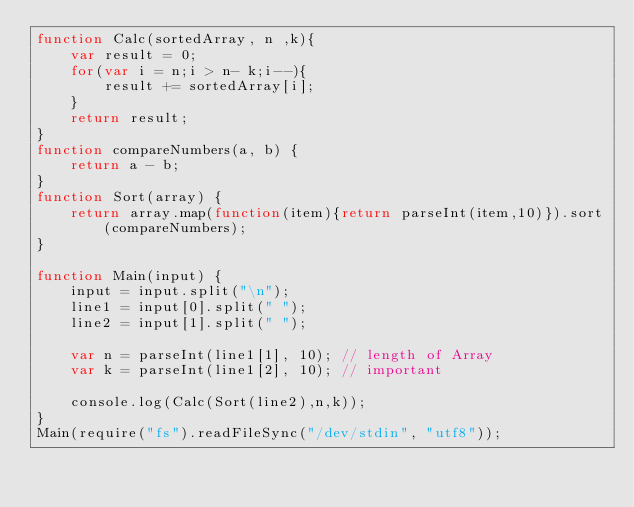<code> <loc_0><loc_0><loc_500><loc_500><_JavaScript_>function Calc(sortedArray, n ,k){
    var result = 0;
    for(var i = n;i > n- k;i--){
        result += sortedArray[i];
    }
    return result;
}
function compareNumbers(a, b) {
    return a - b;
}
function Sort(array) {
    return array.map(function(item){return parseInt(item,10)}).sort(compareNumbers);
}

function Main(input) {
    input = input.split("\n");
    line1 = input[0].split(" ");
    line2 = input[1].split(" ");

    var n = parseInt(line1[1], 10); // length of Array
    var k = parseInt(line1[2], 10); // important

    console.log(Calc(Sort(line2),n,k));
}
Main(require("fs").readFileSync("/dev/stdin", "utf8"));
</code> 